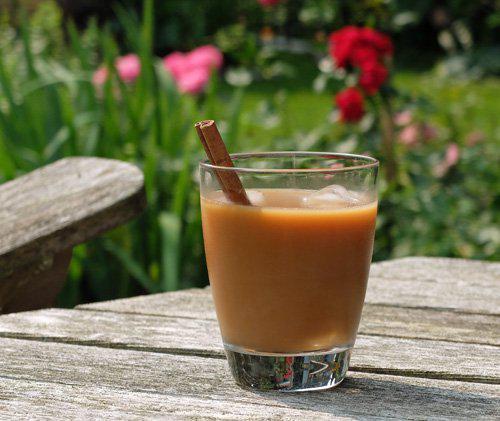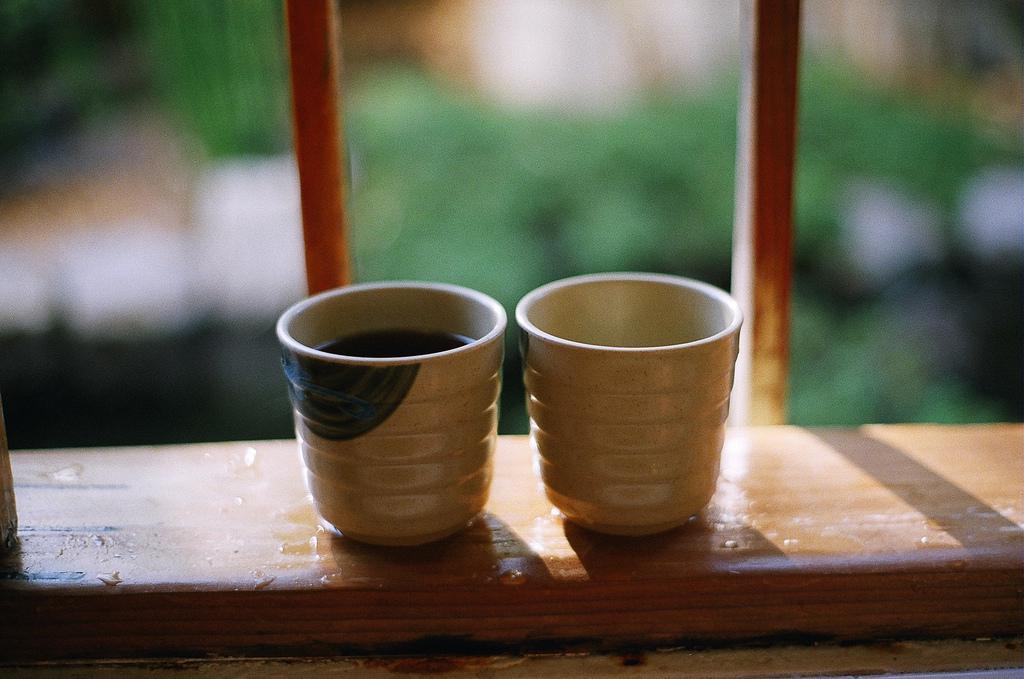The first image is the image on the left, the second image is the image on the right. Analyze the images presented: Is the assertion "Brown liquid sits in a single mug in the cup on the left." valid? Answer yes or no. Yes. The first image is the image on the left, the second image is the image on the right. Evaluate the accuracy of this statement regarding the images: "There are no less than two coffee mugs with handles". Is it true? Answer yes or no. No. 